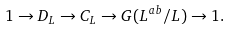Convert formula to latex. <formula><loc_0><loc_0><loc_500><loc_500>1 \to D _ { L } \to C _ { L } \to G ( L ^ { a b } / L ) \to 1 .</formula> 